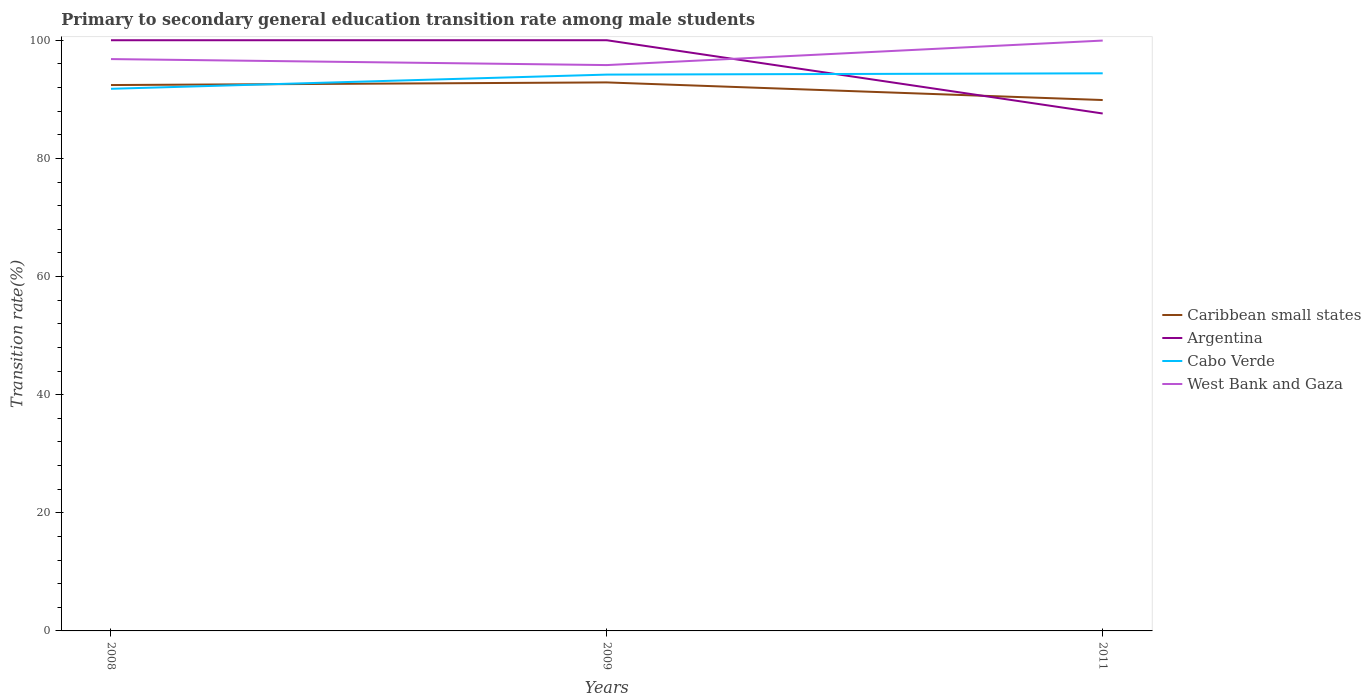Is the number of lines equal to the number of legend labels?
Give a very brief answer. Yes. Across all years, what is the maximum transition rate in Argentina?
Your answer should be very brief. 87.6. What is the total transition rate in Caribbean small states in the graph?
Ensure brevity in your answer.  2.98. What is the difference between the highest and the second highest transition rate in West Bank and Gaza?
Your answer should be very brief. 4.15. What is the difference between the highest and the lowest transition rate in West Bank and Gaza?
Your response must be concise. 1. Is the transition rate in Caribbean small states strictly greater than the transition rate in Argentina over the years?
Your answer should be very brief. No. What is the difference between two consecutive major ticks on the Y-axis?
Give a very brief answer. 20. Are the values on the major ticks of Y-axis written in scientific E-notation?
Keep it short and to the point. No. Where does the legend appear in the graph?
Your response must be concise. Center right. How are the legend labels stacked?
Ensure brevity in your answer.  Vertical. What is the title of the graph?
Provide a short and direct response. Primary to secondary general education transition rate among male students. Does "Congo (Republic)" appear as one of the legend labels in the graph?
Offer a terse response. No. What is the label or title of the Y-axis?
Your answer should be compact. Transition rate(%). What is the Transition rate(%) of Caribbean small states in 2008?
Your answer should be very brief. 92.42. What is the Transition rate(%) of Argentina in 2008?
Make the answer very short. 100. What is the Transition rate(%) in Cabo Verde in 2008?
Offer a very short reply. 91.78. What is the Transition rate(%) of West Bank and Gaza in 2008?
Provide a short and direct response. 96.81. What is the Transition rate(%) in Caribbean small states in 2009?
Offer a terse response. 92.86. What is the Transition rate(%) in Cabo Verde in 2009?
Your response must be concise. 94.18. What is the Transition rate(%) of West Bank and Gaza in 2009?
Offer a terse response. 95.8. What is the Transition rate(%) of Caribbean small states in 2011?
Make the answer very short. 89.88. What is the Transition rate(%) of Argentina in 2011?
Your answer should be compact. 87.6. What is the Transition rate(%) in Cabo Verde in 2011?
Keep it short and to the point. 94.4. What is the Transition rate(%) in West Bank and Gaza in 2011?
Your response must be concise. 99.94. Across all years, what is the maximum Transition rate(%) in Caribbean small states?
Make the answer very short. 92.86. Across all years, what is the maximum Transition rate(%) in Argentina?
Your answer should be compact. 100. Across all years, what is the maximum Transition rate(%) in Cabo Verde?
Ensure brevity in your answer.  94.4. Across all years, what is the maximum Transition rate(%) of West Bank and Gaza?
Give a very brief answer. 99.94. Across all years, what is the minimum Transition rate(%) of Caribbean small states?
Provide a short and direct response. 89.88. Across all years, what is the minimum Transition rate(%) in Argentina?
Offer a very short reply. 87.6. Across all years, what is the minimum Transition rate(%) in Cabo Verde?
Provide a succinct answer. 91.78. Across all years, what is the minimum Transition rate(%) of West Bank and Gaza?
Give a very brief answer. 95.8. What is the total Transition rate(%) in Caribbean small states in the graph?
Ensure brevity in your answer.  275.15. What is the total Transition rate(%) in Argentina in the graph?
Keep it short and to the point. 287.6. What is the total Transition rate(%) in Cabo Verde in the graph?
Give a very brief answer. 280.36. What is the total Transition rate(%) in West Bank and Gaza in the graph?
Your response must be concise. 292.55. What is the difference between the Transition rate(%) of Caribbean small states in 2008 and that in 2009?
Your answer should be compact. -0.44. What is the difference between the Transition rate(%) in Cabo Verde in 2008 and that in 2009?
Ensure brevity in your answer.  -2.4. What is the difference between the Transition rate(%) of West Bank and Gaza in 2008 and that in 2009?
Offer a very short reply. 1.02. What is the difference between the Transition rate(%) in Caribbean small states in 2008 and that in 2011?
Your answer should be compact. 2.54. What is the difference between the Transition rate(%) in Argentina in 2008 and that in 2011?
Make the answer very short. 12.4. What is the difference between the Transition rate(%) in Cabo Verde in 2008 and that in 2011?
Make the answer very short. -2.62. What is the difference between the Transition rate(%) of West Bank and Gaza in 2008 and that in 2011?
Provide a succinct answer. -3.13. What is the difference between the Transition rate(%) in Caribbean small states in 2009 and that in 2011?
Make the answer very short. 2.98. What is the difference between the Transition rate(%) of Argentina in 2009 and that in 2011?
Provide a succinct answer. 12.4. What is the difference between the Transition rate(%) in Cabo Verde in 2009 and that in 2011?
Provide a short and direct response. -0.22. What is the difference between the Transition rate(%) of West Bank and Gaza in 2009 and that in 2011?
Your response must be concise. -4.15. What is the difference between the Transition rate(%) in Caribbean small states in 2008 and the Transition rate(%) in Argentina in 2009?
Your response must be concise. -7.58. What is the difference between the Transition rate(%) in Caribbean small states in 2008 and the Transition rate(%) in Cabo Verde in 2009?
Offer a very short reply. -1.77. What is the difference between the Transition rate(%) in Caribbean small states in 2008 and the Transition rate(%) in West Bank and Gaza in 2009?
Give a very brief answer. -3.38. What is the difference between the Transition rate(%) of Argentina in 2008 and the Transition rate(%) of Cabo Verde in 2009?
Make the answer very short. 5.82. What is the difference between the Transition rate(%) in Argentina in 2008 and the Transition rate(%) in West Bank and Gaza in 2009?
Your answer should be very brief. 4.2. What is the difference between the Transition rate(%) of Cabo Verde in 2008 and the Transition rate(%) of West Bank and Gaza in 2009?
Your response must be concise. -4.02. What is the difference between the Transition rate(%) in Caribbean small states in 2008 and the Transition rate(%) in Argentina in 2011?
Ensure brevity in your answer.  4.82. What is the difference between the Transition rate(%) of Caribbean small states in 2008 and the Transition rate(%) of Cabo Verde in 2011?
Offer a terse response. -1.99. What is the difference between the Transition rate(%) in Caribbean small states in 2008 and the Transition rate(%) in West Bank and Gaza in 2011?
Give a very brief answer. -7.53. What is the difference between the Transition rate(%) in Argentina in 2008 and the Transition rate(%) in Cabo Verde in 2011?
Offer a terse response. 5.6. What is the difference between the Transition rate(%) of Argentina in 2008 and the Transition rate(%) of West Bank and Gaza in 2011?
Offer a terse response. 0.06. What is the difference between the Transition rate(%) in Cabo Verde in 2008 and the Transition rate(%) in West Bank and Gaza in 2011?
Keep it short and to the point. -8.17. What is the difference between the Transition rate(%) in Caribbean small states in 2009 and the Transition rate(%) in Argentina in 2011?
Provide a succinct answer. 5.26. What is the difference between the Transition rate(%) in Caribbean small states in 2009 and the Transition rate(%) in Cabo Verde in 2011?
Your answer should be very brief. -1.54. What is the difference between the Transition rate(%) in Caribbean small states in 2009 and the Transition rate(%) in West Bank and Gaza in 2011?
Your answer should be very brief. -7.08. What is the difference between the Transition rate(%) of Argentina in 2009 and the Transition rate(%) of Cabo Verde in 2011?
Your answer should be very brief. 5.6. What is the difference between the Transition rate(%) in Argentina in 2009 and the Transition rate(%) in West Bank and Gaza in 2011?
Your answer should be compact. 0.06. What is the difference between the Transition rate(%) of Cabo Verde in 2009 and the Transition rate(%) of West Bank and Gaza in 2011?
Give a very brief answer. -5.76. What is the average Transition rate(%) in Caribbean small states per year?
Provide a succinct answer. 91.72. What is the average Transition rate(%) of Argentina per year?
Give a very brief answer. 95.87. What is the average Transition rate(%) of Cabo Verde per year?
Give a very brief answer. 93.45. What is the average Transition rate(%) in West Bank and Gaza per year?
Your answer should be very brief. 97.52. In the year 2008, what is the difference between the Transition rate(%) in Caribbean small states and Transition rate(%) in Argentina?
Provide a succinct answer. -7.58. In the year 2008, what is the difference between the Transition rate(%) in Caribbean small states and Transition rate(%) in Cabo Verde?
Make the answer very short. 0.64. In the year 2008, what is the difference between the Transition rate(%) of Caribbean small states and Transition rate(%) of West Bank and Gaza?
Provide a short and direct response. -4.4. In the year 2008, what is the difference between the Transition rate(%) in Argentina and Transition rate(%) in Cabo Verde?
Your answer should be compact. 8.22. In the year 2008, what is the difference between the Transition rate(%) of Argentina and Transition rate(%) of West Bank and Gaza?
Ensure brevity in your answer.  3.19. In the year 2008, what is the difference between the Transition rate(%) in Cabo Verde and Transition rate(%) in West Bank and Gaza?
Offer a very short reply. -5.03. In the year 2009, what is the difference between the Transition rate(%) in Caribbean small states and Transition rate(%) in Argentina?
Offer a terse response. -7.14. In the year 2009, what is the difference between the Transition rate(%) of Caribbean small states and Transition rate(%) of Cabo Verde?
Offer a very short reply. -1.32. In the year 2009, what is the difference between the Transition rate(%) in Caribbean small states and Transition rate(%) in West Bank and Gaza?
Offer a very short reply. -2.94. In the year 2009, what is the difference between the Transition rate(%) of Argentina and Transition rate(%) of Cabo Verde?
Make the answer very short. 5.82. In the year 2009, what is the difference between the Transition rate(%) in Argentina and Transition rate(%) in West Bank and Gaza?
Provide a succinct answer. 4.2. In the year 2009, what is the difference between the Transition rate(%) of Cabo Verde and Transition rate(%) of West Bank and Gaza?
Keep it short and to the point. -1.61. In the year 2011, what is the difference between the Transition rate(%) of Caribbean small states and Transition rate(%) of Argentina?
Give a very brief answer. 2.28. In the year 2011, what is the difference between the Transition rate(%) of Caribbean small states and Transition rate(%) of Cabo Verde?
Offer a terse response. -4.53. In the year 2011, what is the difference between the Transition rate(%) of Caribbean small states and Transition rate(%) of West Bank and Gaza?
Provide a short and direct response. -10.07. In the year 2011, what is the difference between the Transition rate(%) of Argentina and Transition rate(%) of Cabo Verde?
Your answer should be compact. -6.81. In the year 2011, what is the difference between the Transition rate(%) of Argentina and Transition rate(%) of West Bank and Gaza?
Your response must be concise. -12.35. In the year 2011, what is the difference between the Transition rate(%) in Cabo Verde and Transition rate(%) in West Bank and Gaza?
Provide a short and direct response. -5.54. What is the ratio of the Transition rate(%) in Caribbean small states in 2008 to that in 2009?
Keep it short and to the point. 1. What is the ratio of the Transition rate(%) in Cabo Verde in 2008 to that in 2009?
Offer a terse response. 0.97. What is the ratio of the Transition rate(%) of West Bank and Gaza in 2008 to that in 2009?
Make the answer very short. 1.01. What is the ratio of the Transition rate(%) of Caribbean small states in 2008 to that in 2011?
Give a very brief answer. 1.03. What is the ratio of the Transition rate(%) in Argentina in 2008 to that in 2011?
Give a very brief answer. 1.14. What is the ratio of the Transition rate(%) in Cabo Verde in 2008 to that in 2011?
Give a very brief answer. 0.97. What is the ratio of the Transition rate(%) in West Bank and Gaza in 2008 to that in 2011?
Your answer should be very brief. 0.97. What is the ratio of the Transition rate(%) of Caribbean small states in 2009 to that in 2011?
Offer a very short reply. 1.03. What is the ratio of the Transition rate(%) of Argentina in 2009 to that in 2011?
Your answer should be very brief. 1.14. What is the ratio of the Transition rate(%) of West Bank and Gaza in 2009 to that in 2011?
Offer a very short reply. 0.96. What is the difference between the highest and the second highest Transition rate(%) of Caribbean small states?
Give a very brief answer. 0.44. What is the difference between the highest and the second highest Transition rate(%) of Cabo Verde?
Offer a very short reply. 0.22. What is the difference between the highest and the second highest Transition rate(%) of West Bank and Gaza?
Your answer should be compact. 3.13. What is the difference between the highest and the lowest Transition rate(%) in Caribbean small states?
Your answer should be very brief. 2.98. What is the difference between the highest and the lowest Transition rate(%) in Argentina?
Offer a very short reply. 12.4. What is the difference between the highest and the lowest Transition rate(%) of Cabo Verde?
Your response must be concise. 2.62. What is the difference between the highest and the lowest Transition rate(%) of West Bank and Gaza?
Keep it short and to the point. 4.15. 